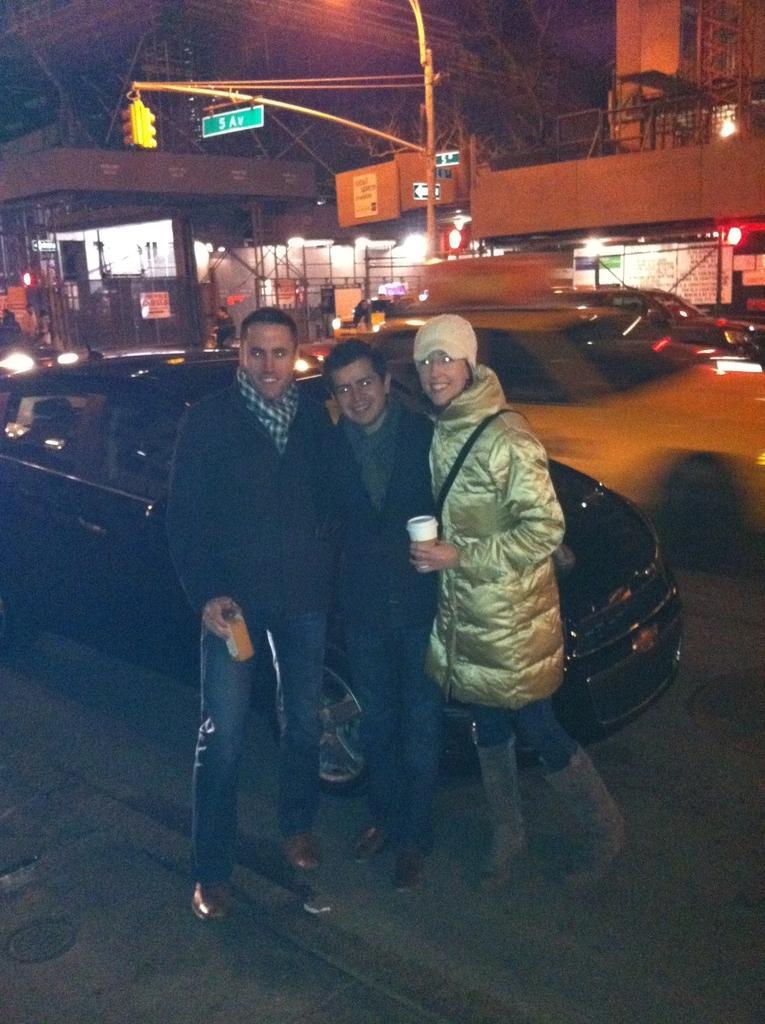In one or two sentences, can you explain what this image depicts? In this picture I can observe three members standing on the ground. Behind them there is a black color car on the road. In the background I can observe a pole and some buildings. 